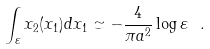Convert formula to latex. <formula><loc_0><loc_0><loc_500><loc_500>\int _ { \varepsilon } x _ { 2 } ( x _ { 1 } ) d x _ { 1 } \simeq - \frac { 4 } { \pi a ^ { 2 } } \log \varepsilon \ .</formula> 